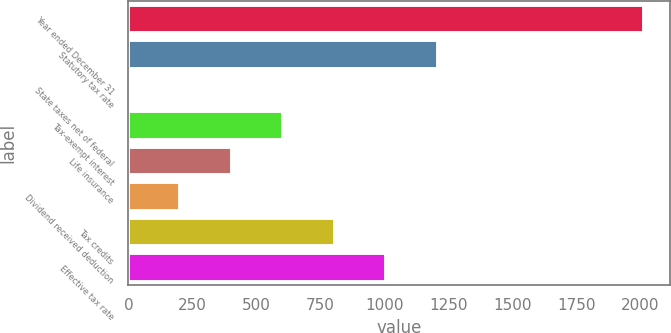<chart> <loc_0><loc_0><loc_500><loc_500><bar_chart><fcel>Year ended December 31<fcel>Statutory tax rate<fcel>State taxes net of federal<fcel>Tax-exempt interest<fcel>Life insurance<fcel>Dividend received deduction<fcel>Tax credits<fcel>Effective tax rate<nl><fcel>2014<fcel>1208.88<fcel>1.2<fcel>605.04<fcel>403.76<fcel>202.48<fcel>806.32<fcel>1007.6<nl></chart> 